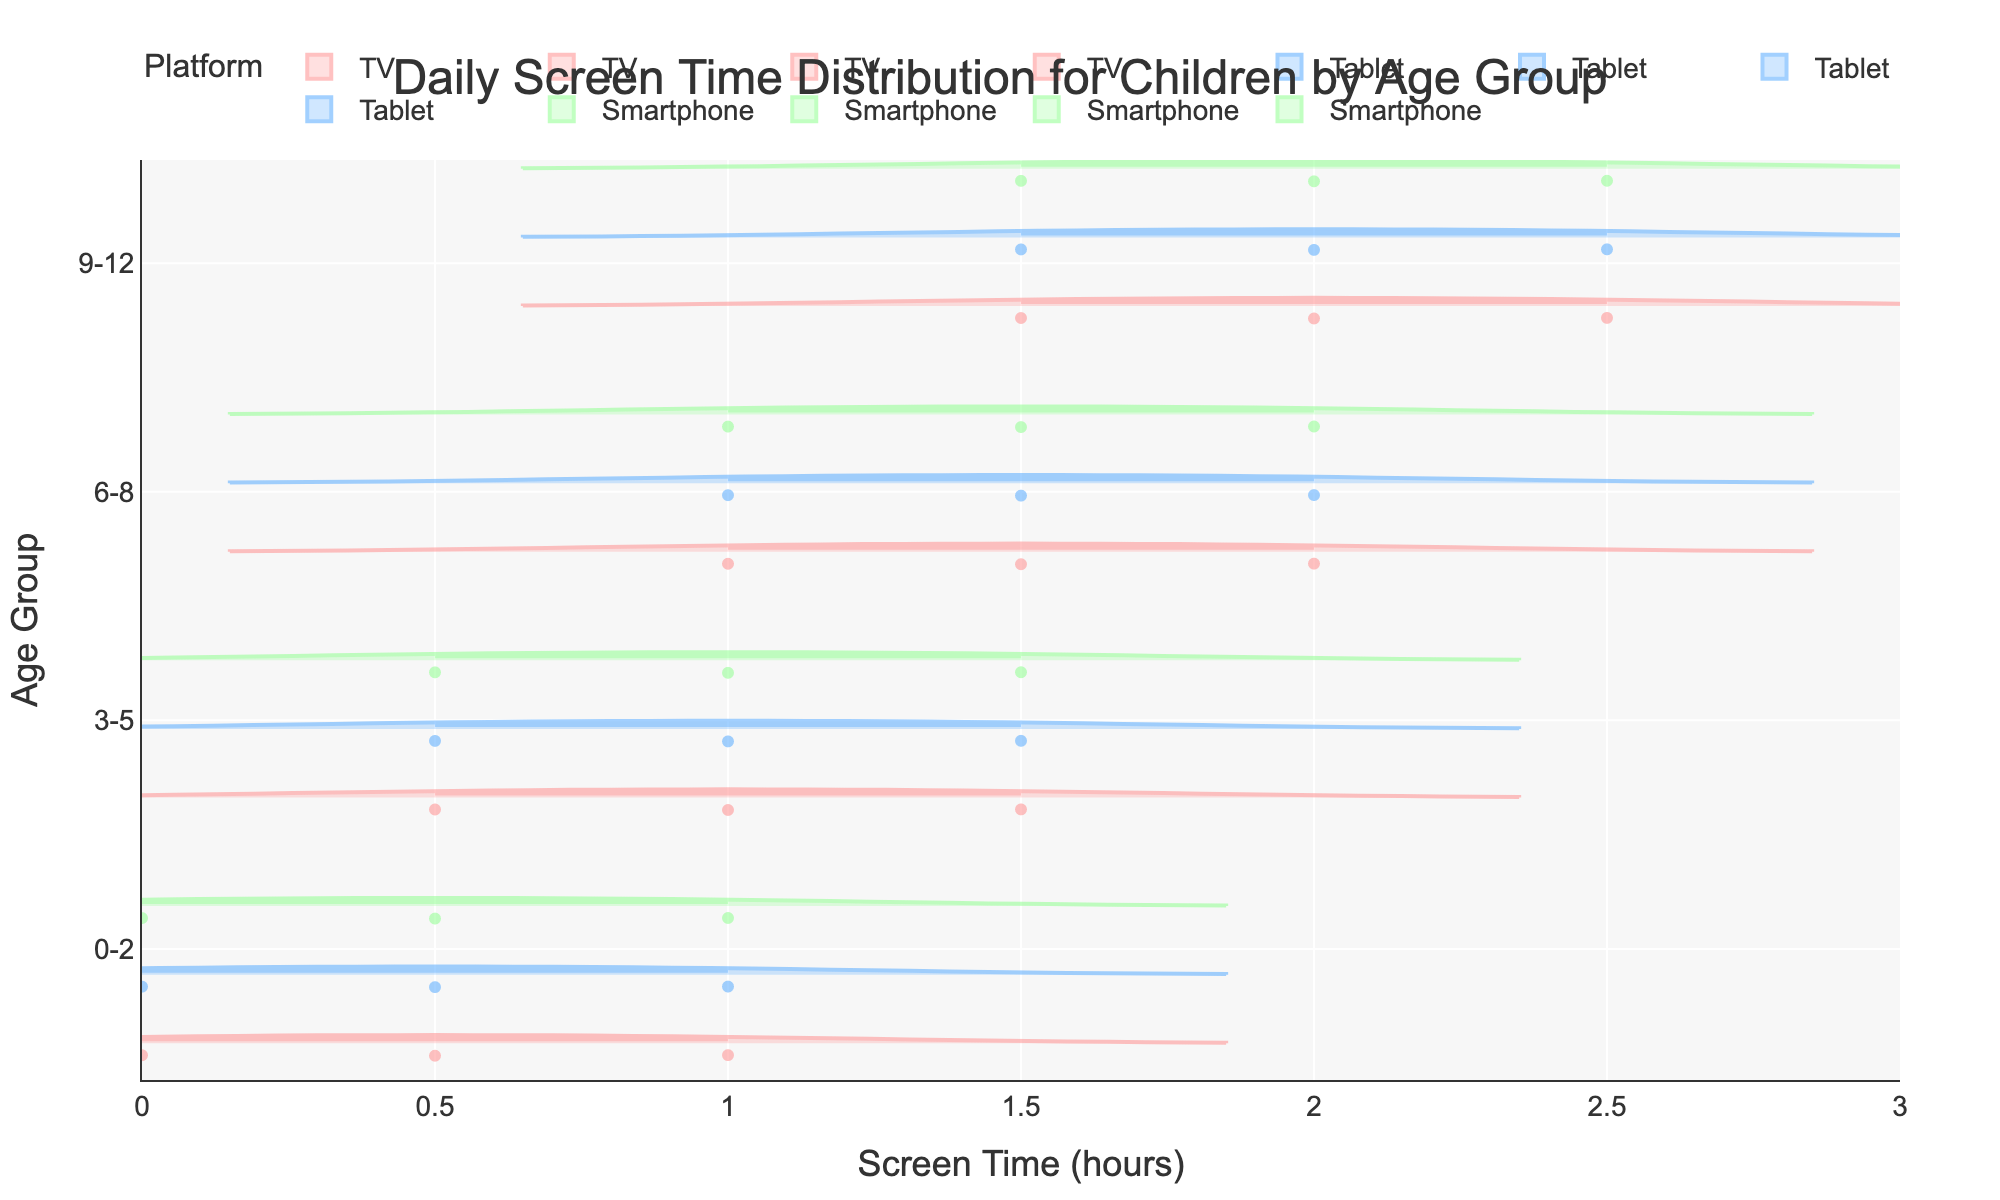What is the title of the figure? The title of the figure is prominently displayed at the top of the chart.
Answer: Daily Screen Time Distribution for Children by Age Group What are the platforms represented in the figure? The platforms are indicated in the legend and by the colors used in the violin plots.
Answer: TV, Tablet, Smartphone What age group spends the most time on screens on average? By examining the horizontal violins and the mean lines, we can see which age group has the highest average screen time.
Answer: 9-12 How does the screen time distribution for the 3-5 age group compare to the 6-8 age group? By looking at the shapes and spread of the violins, we compare the width and length for 3-5 and 6-8 age groups.
Answer: The 6-8 age group has a wider distribution with higher screen times Which platform has the least variation in screen time for children aged 0-2? Looking at the width of the violins for the 0-2 age group across all platforms, we identify the narrowest one.
Answer: TV What is the maximum screen time observed in the 9-12 age group and for which platform? The highest point on the x-axis within the 9-12 group violins indicates the maximum screen time per platform.
Answer: 2.5 hours, TV, Tablet, Smartphone Is there a significant overlap in screen time between platforms for the 6-8 age group? By observing the horizontal spread of the violin plots for the 6-8 group, we can see how much the distributions overlap.
Answer: Yes Which age group shows the most balanced screen time usage across different platforms? By comparing the violins for each age group, we check which group has similar distributions and central tendencies across platforms.
Answer: 3-5 